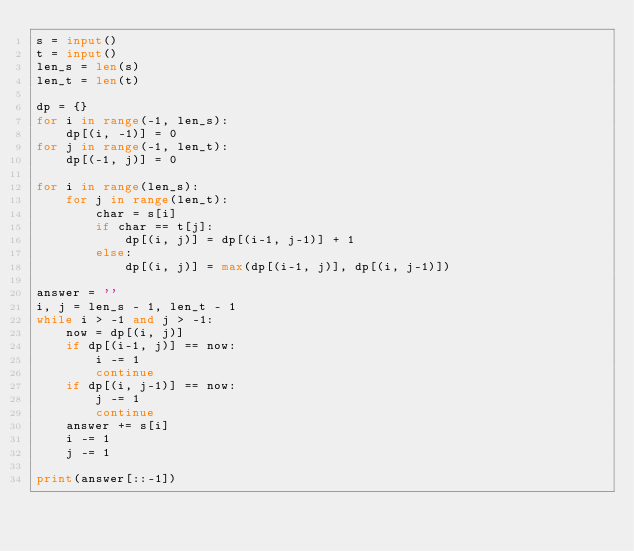Convert code to text. <code><loc_0><loc_0><loc_500><loc_500><_Python_>s = input()
t = input()
len_s = len(s)
len_t = len(t)

dp = {}
for i in range(-1, len_s):
    dp[(i, -1)] = 0
for j in range(-1, len_t):
    dp[(-1, j)] = 0

for i in range(len_s):
    for j in range(len_t):
        char = s[i]
        if char == t[j]:
            dp[(i, j)] = dp[(i-1, j-1)] + 1
        else:
            dp[(i, j)] = max(dp[(i-1, j)], dp[(i, j-1)])

answer = ''
i, j = len_s - 1, len_t - 1
while i > -1 and j > -1:
    now = dp[(i, j)]
    if dp[(i-1, j)] == now:
        i -= 1
        continue
    if dp[(i, j-1)] == now:
        j -= 1
        continue
    answer += s[i]
    i -= 1
    j -= 1

print(answer[::-1])
</code> 